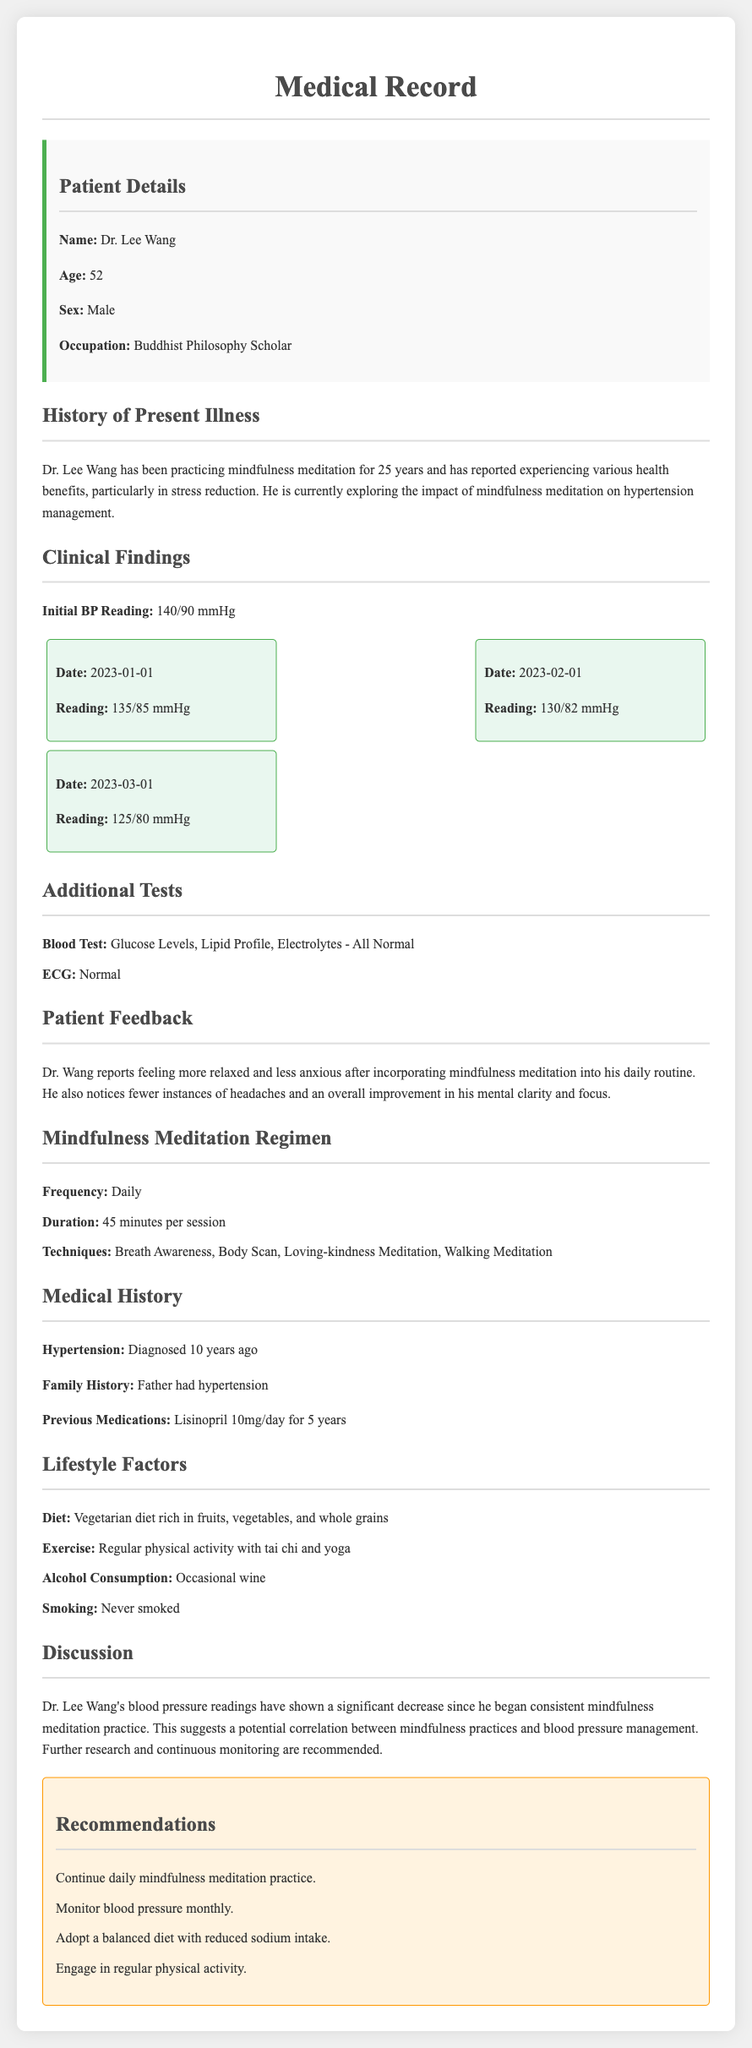What is the patient's name? The patient's name is given in the patient details section.
Answer: Dr. Lee Wang How many years has the patient been practicing mindfulness meditation? The document states that Dr. Lee Wang has been practicing mindfulness meditation for 25 years.
Answer: 25 years What was the initial blood pressure reading? The initial blood pressure reading is mentioned under clinical findings.
Answer: 140/90 mmHg What date was the blood pressure reading 125/80 mmHg taken? The document lists various blood pressure readings with corresponding dates.
Answer: 2023-03-01 What is the patient's occupation? The patient's occupation is specified in the patient details section.
Answer: Buddhist Philosophy Scholar What benefits does Dr. Wang report from mindfulness meditation? The document mentions specific health benefits experienced by Dr. Wang due to meditation practice.
Answer: Relaxed and less anxious What technique is not part of Dr. Wang's mindfulness meditation regimen? The document lists various techniques in the mindfulness meditation regimen section.
Answer: Not applicable (all listed techniques are part of the regimen) What medication did the patient take prior to mindfulness meditation? The medical history section specifies the previous medication taken by Dr. Wang.
Answer: Lisinopril 10mg/day What lifestyle factor is mentioned regarding the patient's alcohol consumption? The lifestyle factors section outlines the patient's habits, including alcohol.
Answer: Occasional wine 